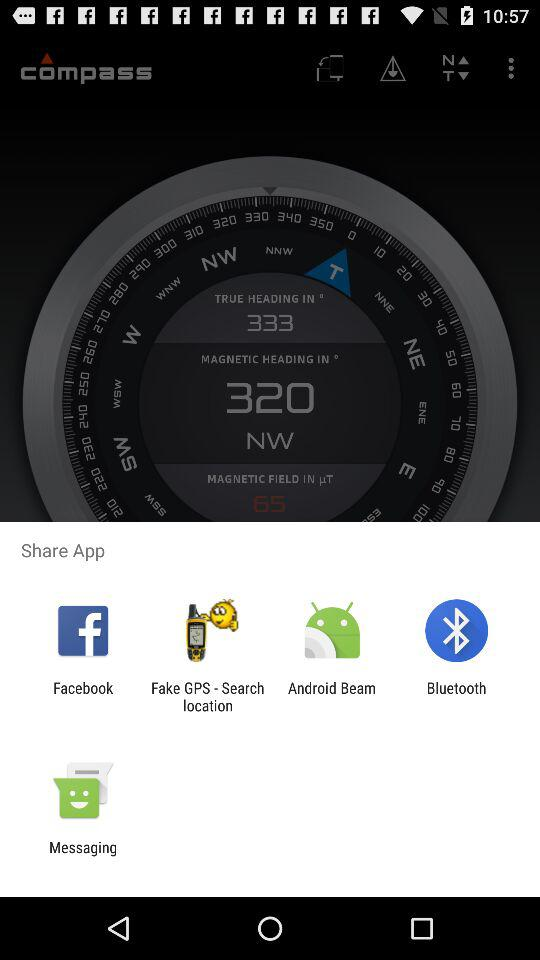What is the magnetic heading that is displayed? The displayed magnetic heading is 320 degrees NW. 